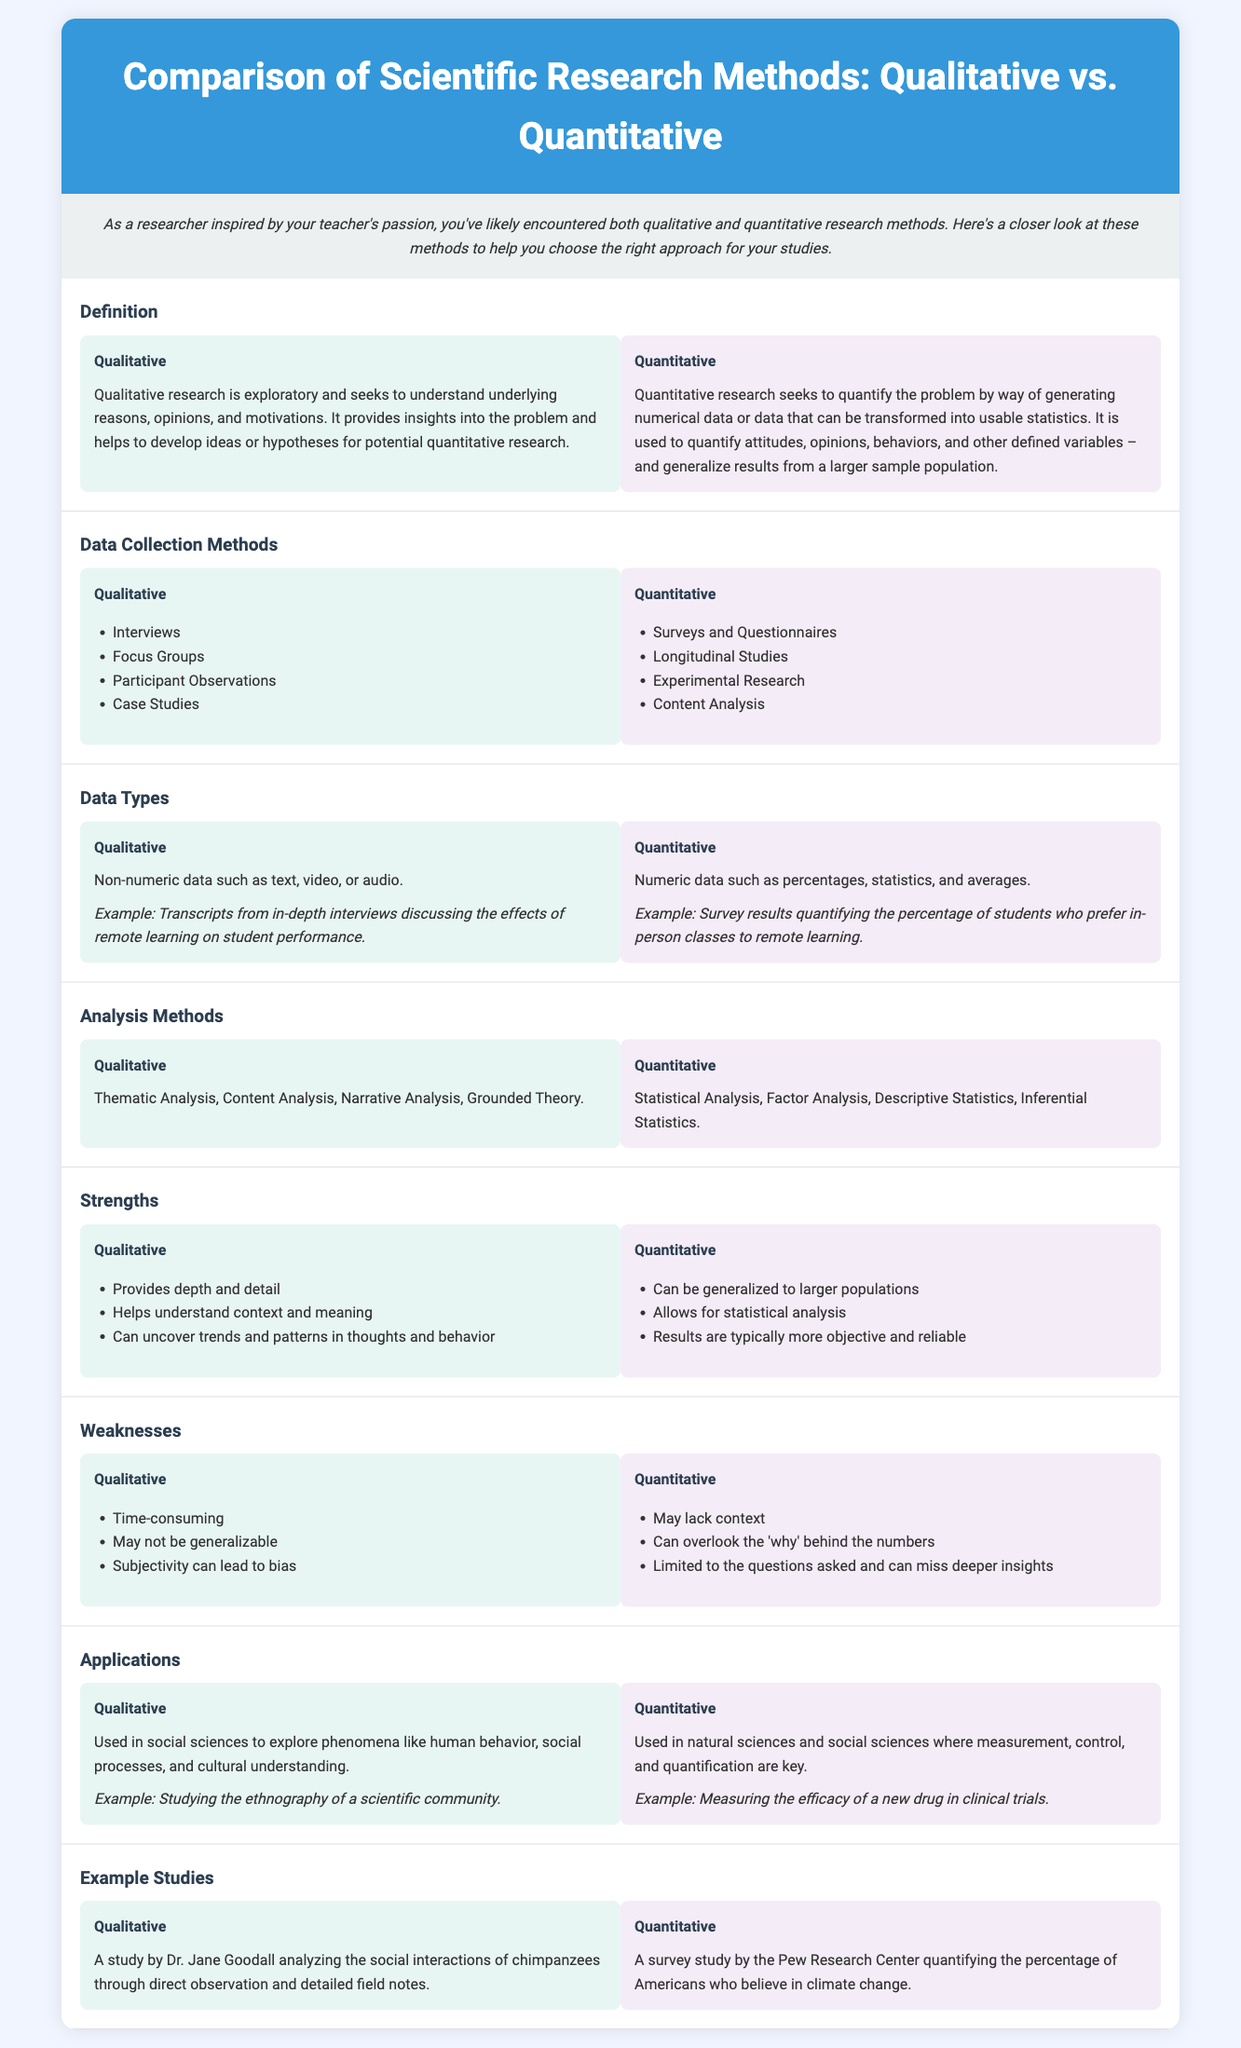What is the main focus of qualitative research? The main focus of qualitative research is to understand underlying reasons, opinions, and motivations.
Answer: Understand underlying reasons, opinions, and motivations List two data collection methods used in qualitative research. The document details data collection methods for qualitative research, including interviews and focus groups.
Answer: Interviews, Focus Groups What type of data does quantitative research generate? Quantitative research generates numeric data, which can include percentages and statistics.
Answer: Numeric data What is one strength of qualitative research? The document mentions that qualitative research provides depth and detail as one of its strengths.
Answer: Provides depth and detail Which application is qualitative research particularly suited for? Qualitative research is particularly suited for exploring human behavior and social processes in social sciences.
Answer: Human behavior, social processes Name one analysis method used in quantitative research. The document lists several methods, with statistical analysis being one of them.
Answer: Statistical Analysis What is a weakness of quantitative research? Quantitative research may lack context according to the document which discusses its weaknesses.
Answer: May lack context Provide an example of qualitative research mentioned in the document. The document refers to Dr. Jane Goodall's study on chimpanzee social interactions as a qualitative research example.
Answer: Dr. Jane Goodall's study on chimpanzees What kind of studies commonly utilize quantitative research methods? Quantitative research methods are commonly utilized in natural sciences and social sciences where measurement is key.
Answer: Natural sciences, social sciences 